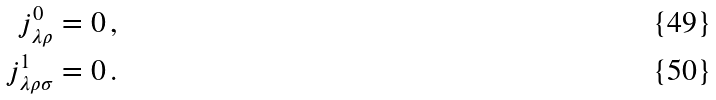<formula> <loc_0><loc_0><loc_500><loc_500>j ^ { 0 } _ { \lambda \rho } & = 0 \, , \\ j ^ { 1 } _ { \lambda \rho \sigma } & = 0 \, .</formula> 